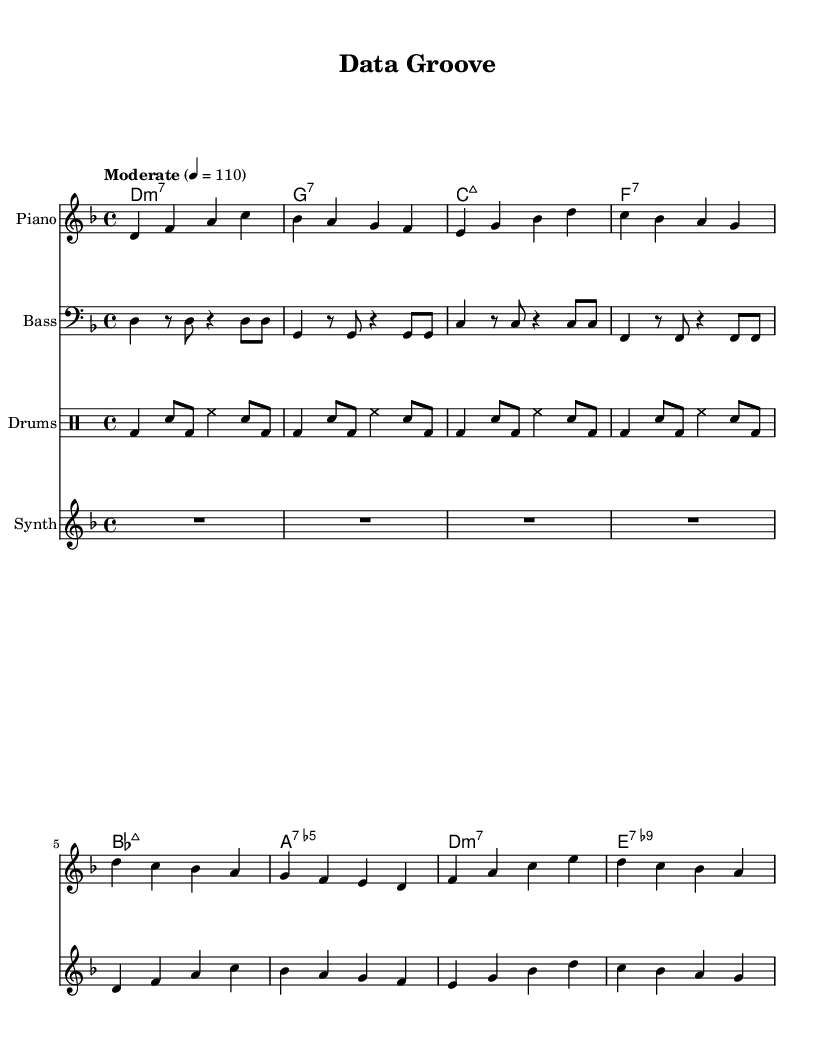what is the key signature of this music? The key signature is indicated at the beginning of the staff and shows that there are one flat (B flat), which corresponds to the key of D minor.
Answer: D minor what is the time signature of this piece? The time signature appears at the beginning of the music sheet, showing that it is in 4/4 time, meaning there are four beats per measure.
Answer: 4/4 what is the tempo marking for this music? The tempo is indicated in the header with the term "Moderate" and a metronome marking of 110 beats per minute, which suggests a moderate pace.
Answer: Moderate, 110 how many measures are there in the piano part? By counting the segmented bars that separate musical phrases in the piano part, there are a total of 8 measures in the shown section of the music.
Answer: 8 which chord is played in the first measure? The chord in the first measure is represented by the chord symbol 'D minor 7' above the piano staff; this is the first chord in the chord progression.
Answer: D minor 7 what instrument plays the melody? The melody is notated on the staff labeled "Synth," which indicates that the synth instrument is the one executing the melodic lines in this arrangement.
Answer: Synth how does the drum pattern begin? The drum pattern starts with the kick drum (bd) being played on the first beat of the first measure, with a snare (sn) hit on the second eighth note.
Answer: Kick drum 